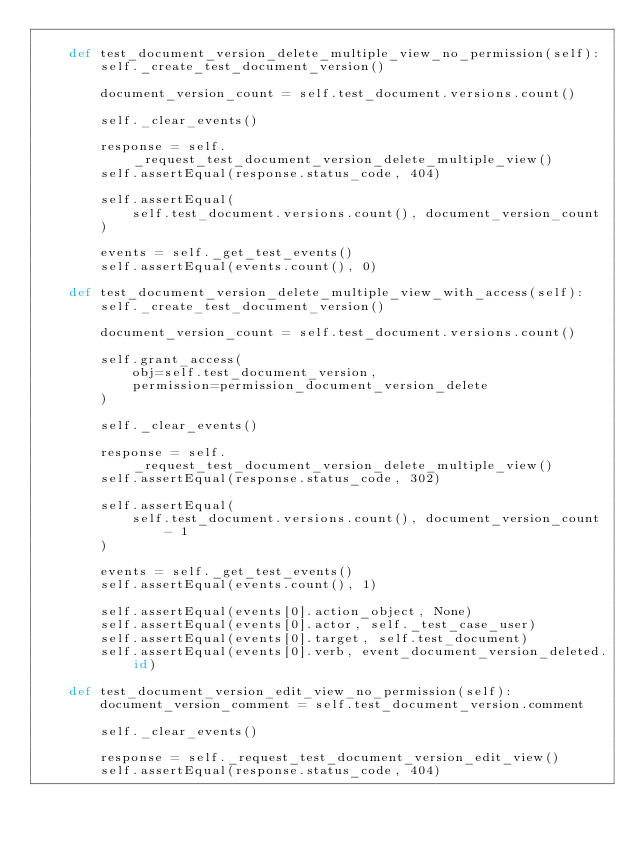Convert code to text. <code><loc_0><loc_0><loc_500><loc_500><_Python_>
    def test_document_version_delete_multiple_view_no_permission(self):
        self._create_test_document_version()

        document_version_count = self.test_document.versions.count()

        self._clear_events()

        response = self._request_test_document_version_delete_multiple_view()
        self.assertEqual(response.status_code, 404)

        self.assertEqual(
            self.test_document.versions.count(), document_version_count
        )

        events = self._get_test_events()
        self.assertEqual(events.count(), 0)

    def test_document_version_delete_multiple_view_with_access(self):
        self._create_test_document_version()

        document_version_count = self.test_document.versions.count()

        self.grant_access(
            obj=self.test_document_version,
            permission=permission_document_version_delete
        )

        self._clear_events()

        response = self._request_test_document_version_delete_multiple_view()
        self.assertEqual(response.status_code, 302)

        self.assertEqual(
            self.test_document.versions.count(), document_version_count - 1
        )

        events = self._get_test_events()
        self.assertEqual(events.count(), 1)

        self.assertEqual(events[0].action_object, None)
        self.assertEqual(events[0].actor, self._test_case_user)
        self.assertEqual(events[0].target, self.test_document)
        self.assertEqual(events[0].verb, event_document_version_deleted.id)

    def test_document_version_edit_view_no_permission(self):
        document_version_comment = self.test_document_version.comment

        self._clear_events()

        response = self._request_test_document_version_edit_view()
        self.assertEqual(response.status_code, 404)
</code> 